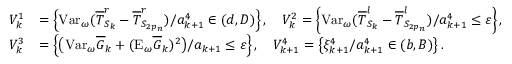Convert formula to latex. <formula><loc_0><loc_0><loc_500><loc_500>\begin{array} { r l } { V _ { k } ^ { 1 } } & { = \left \{ V a r _ { \omega } ( \overline { T } _ { S _ { k } } ^ { r } - \overline { T } _ { S _ { 2 p _ { n } } } ^ { r } ) / { a _ { k + 1 } ^ { 4 } } \in ( d , D ) \right \} , \quad V _ { k } ^ { 2 } = \left \{ V a r _ { \omega } ( \overline { T } _ { S _ { k } } ^ { l } - \overline { T } _ { S _ { 2 p _ { n } } } ^ { l } ) / a _ { k + 1 } ^ { 4 } \leq \varepsilon \right \} , } \\ { V _ { k } ^ { 3 } } & { = \left \{ \left ( V a r _ { \omega } \overline { G } _ { k } + ( E _ { \omega } \overline { G } _ { k } ) ^ { 2 } \right ) / a _ { k + 1 } \leq \varepsilon \right \} , \quad V _ { k + 1 } ^ { 4 } = \left \{ \xi _ { k + 1 } ^ { 4 } / a _ { k + 1 } ^ { 4 } \in ( b , B ) \right \} . } \end{array}</formula> 